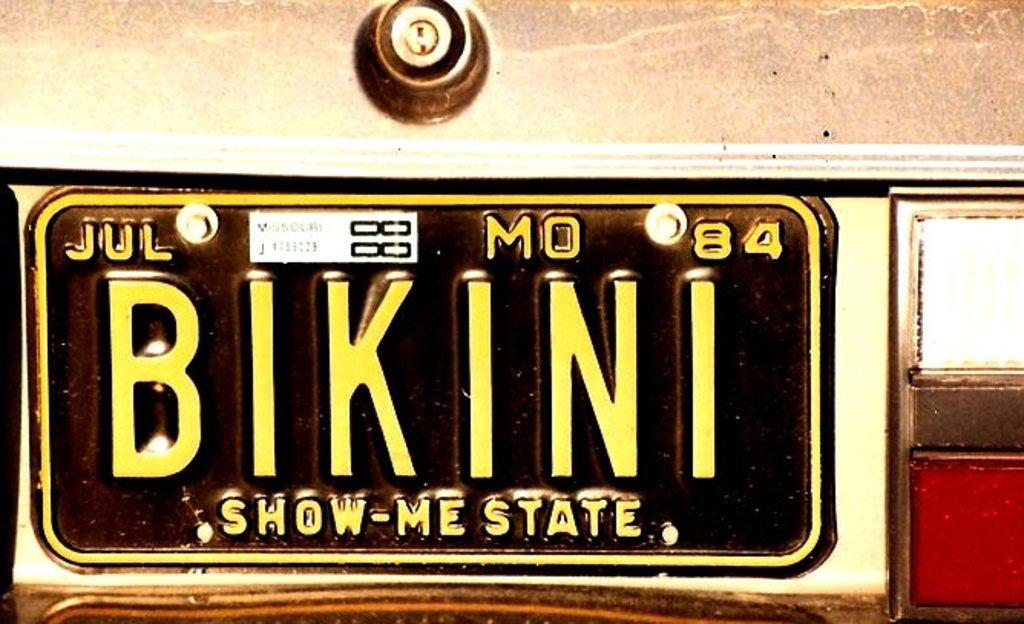What type of swimsuit is listed on this license plate?
Offer a terse response. Bikini. What kind of state is showing?
Offer a very short reply. Mo. 